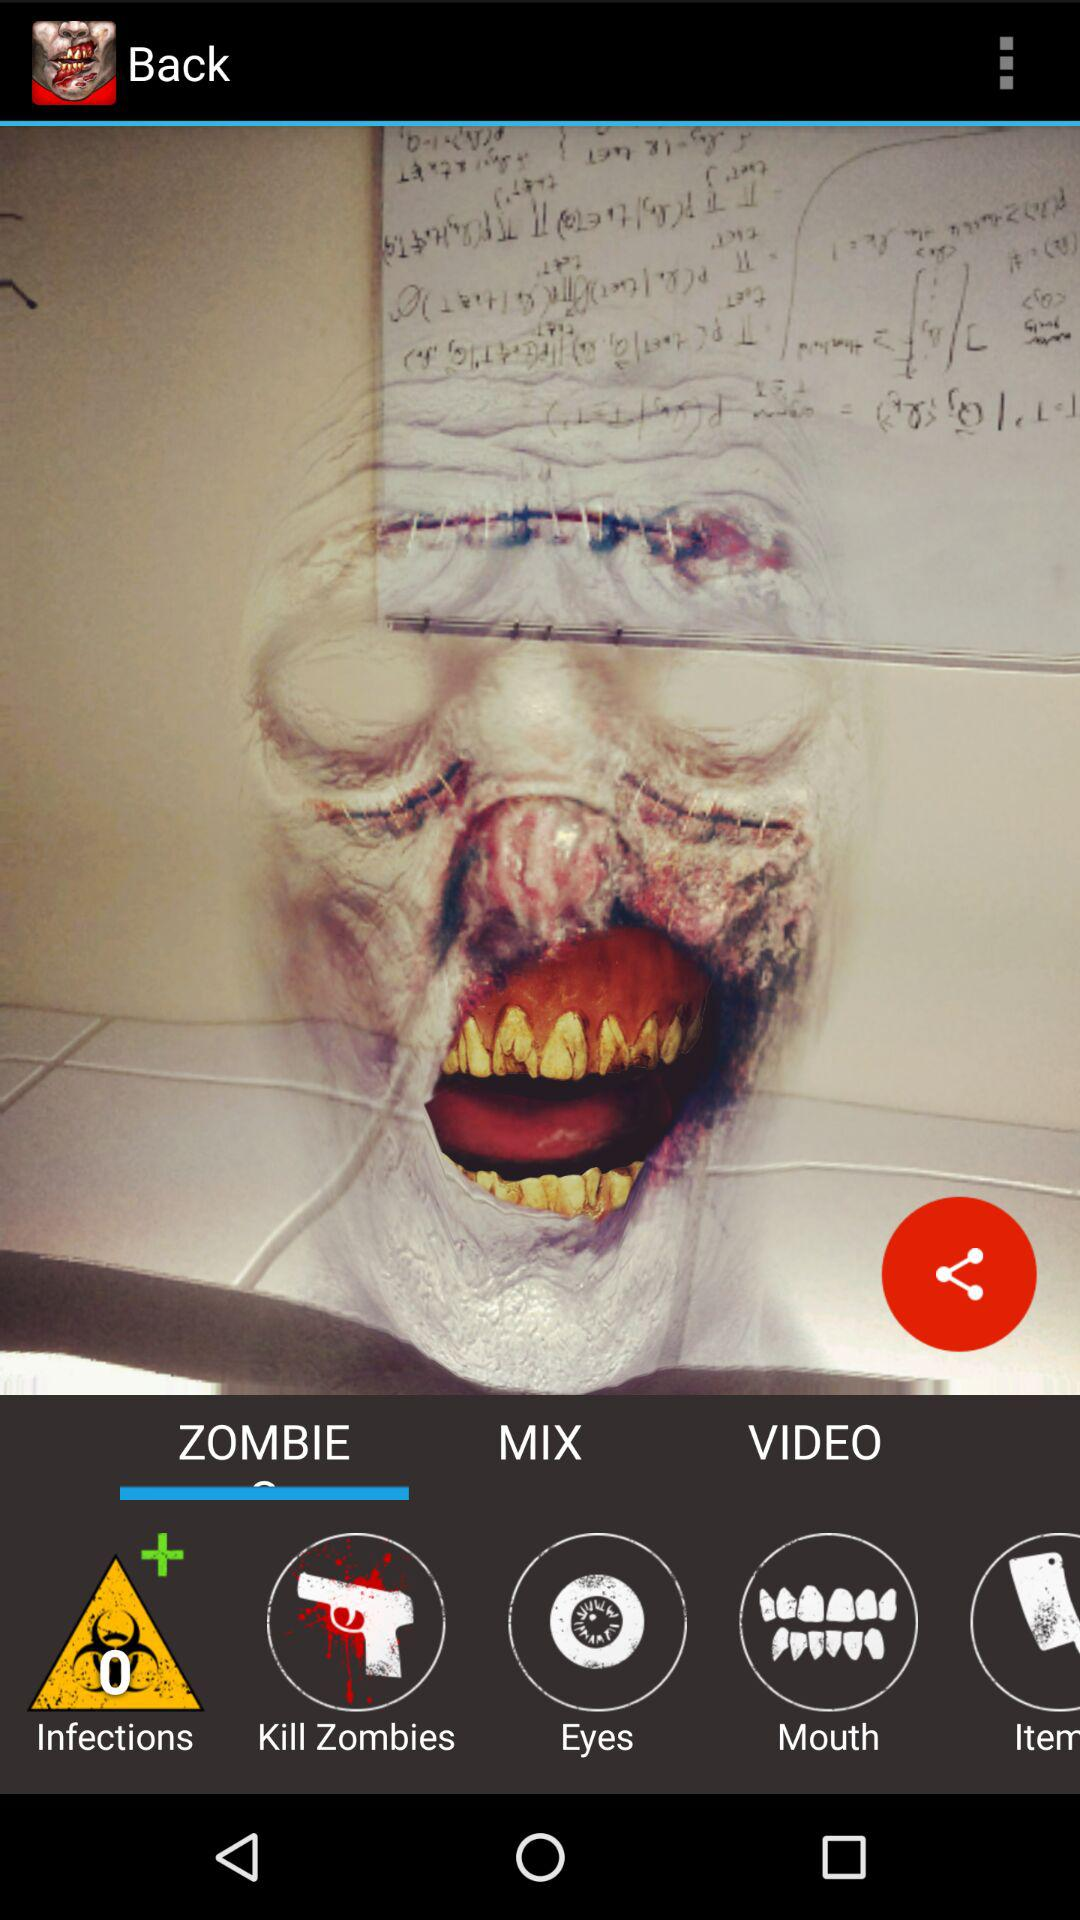Which tab is selected? The selected tab is "ZOMBIE". 